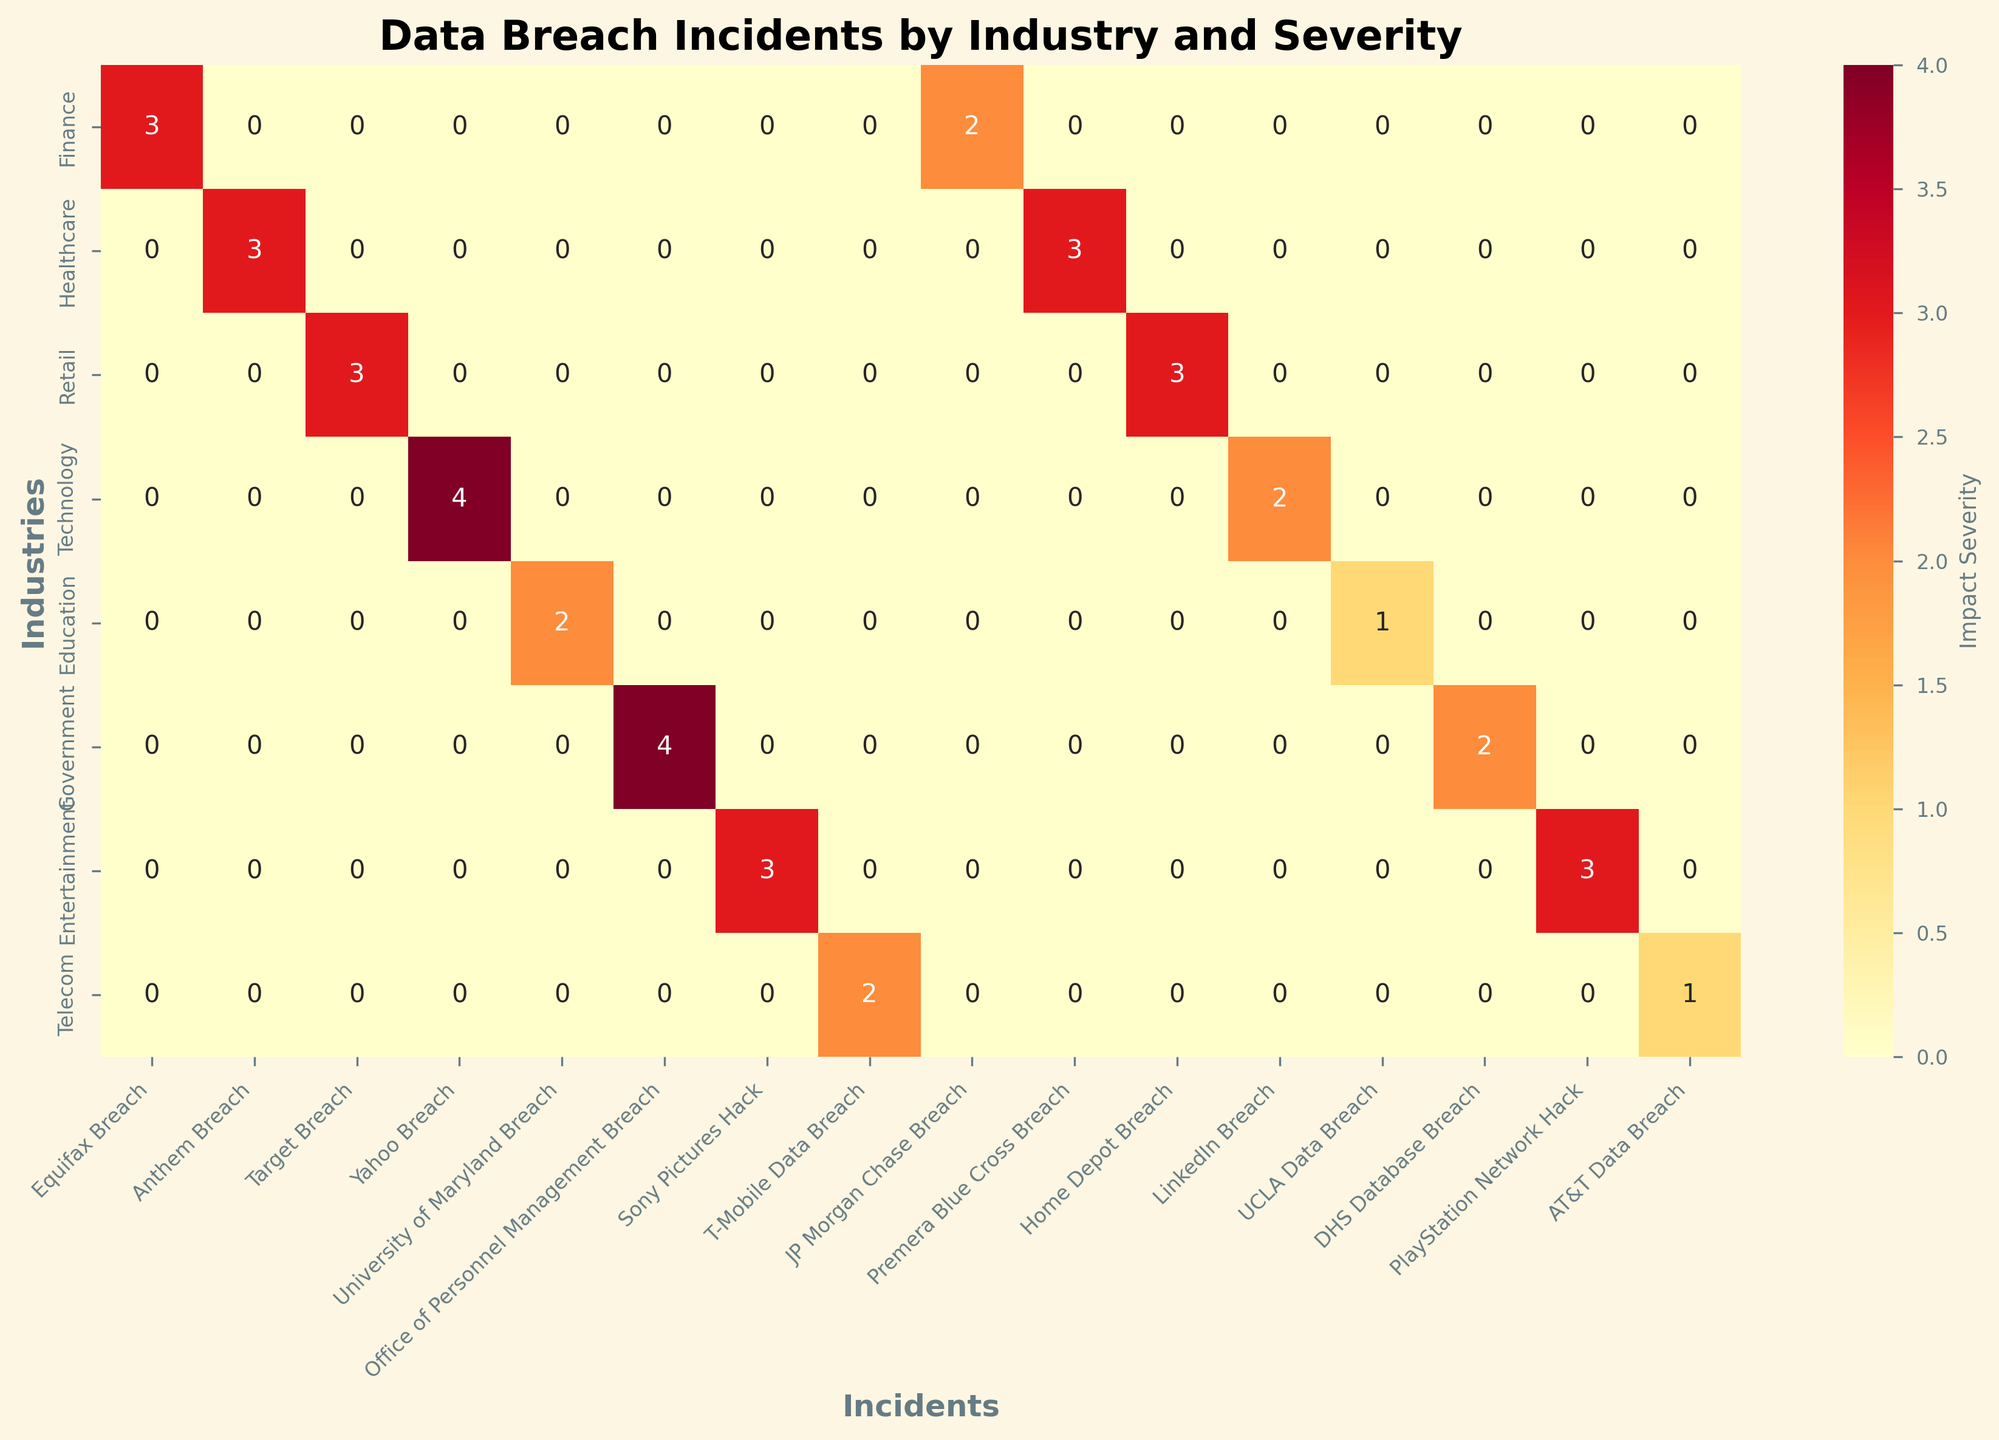What is the title of the heatmap? The title of the heatmap is typically found at the top of the figure and describes the overall content.
Answer: Data Breach Incidents by Industry and Severity Which industry has the highest impact severity for any incident? By scanning the heatmap for the darkest color, which represents the highest severity (Very High), it appears in the Technology and Government rows.
Answer: Technology, Government How many incidents with "High" impact severity are shown for the Finance industry? Look for the Finance row and count the cells colored in the shade indicating "High" severity.
Answer: 1 Which industries experienced incidents with "Low" impact severity? Locate the rows with cells colored corresponding to "Low" severity and note the industries.
Answer: Education, Telecom What is the impact severity of the Anthem Breach in the Healthcare industry? Find the Healthcare row and look at the cell under the Anthem Breach column.
Answer: High Which incident had the highest impact severity in the Technology industry? Within the Technology row, find the darkest-colored cell (Very High) and note the corresponding incident.
Answer: Yahoo Breach How does the impact severity of the Yahoo Breach compare to the LinkedIn Breach in the Technology industry? Compare the colors of the cells in the Technology row for Yahoo and LinkedIn Breaches. Yahoo Breach is Very High (darkest) while LinkedIn is Medium.
Answer: Yahoo is higher Which incident in the Government sector has a Medium impact severity? Look in the Government row for the cell indicating Medium severity and check the corresponding incident.
Answer: DHS Database Breach Are there any industries that did not experience a "Very High" impact severity incident? If so, which ones? Scan through each industry's row and check for the absence of the darkest coloring that indicates "Very High" severity.
Answer: Retail, Education, Entertainment, Telecom What is the common impact severity of incidents in the Healthcare industry? Look for the Healthcare row and observe the most frequent color appearing in its cells. The majority of cells indicate "High" severity.
Answer: High 